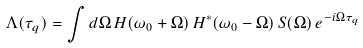Convert formula to latex. <formula><loc_0><loc_0><loc_500><loc_500>\Lambda ( \tau _ { q } ) = \int d \Omega \, H ( \omega _ { 0 } + \Omega ) \, H ^ { \ast } ( \omega _ { 0 } - \Omega ) \, S ( \Omega ) \, e ^ { - i \Omega \tau _ { q } }</formula> 